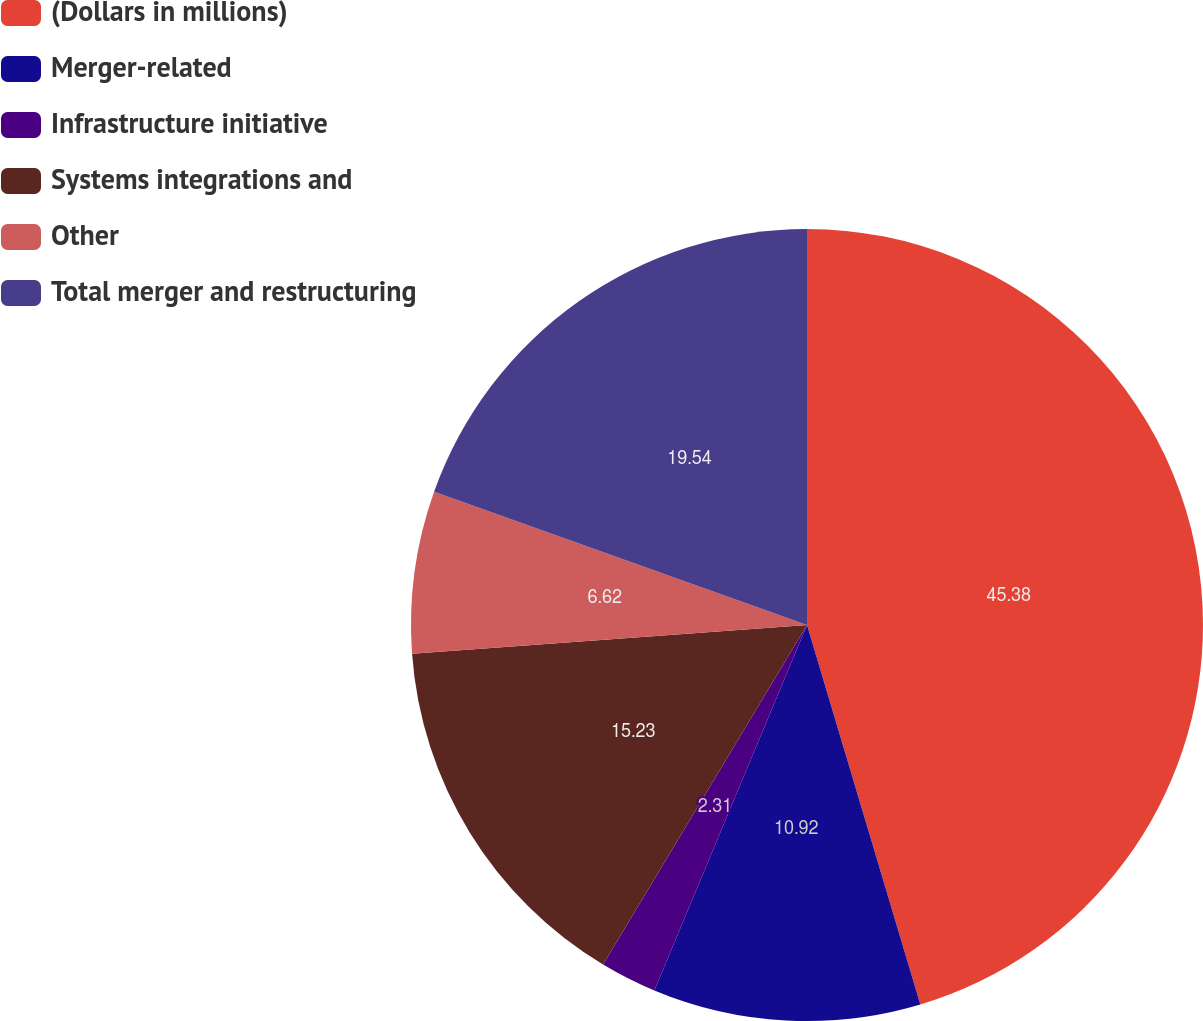Convert chart to OTSL. <chart><loc_0><loc_0><loc_500><loc_500><pie_chart><fcel>(Dollars in millions)<fcel>Merger-related<fcel>Infrastructure initiative<fcel>Systems integrations and<fcel>Other<fcel>Total merger and restructuring<nl><fcel>45.38%<fcel>10.92%<fcel>2.31%<fcel>15.23%<fcel>6.62%<fcel>19.54%<nl></chart> 